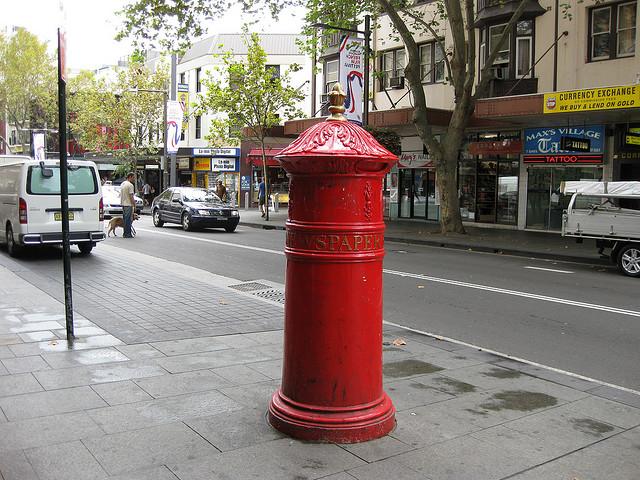Is the window open on the van?
Keep it brief. No. Are these people driving in America?
Concise answer only. No. What color is the parked van?
Keep it brief. White. 